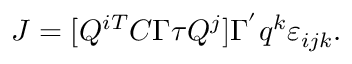<formula> <loc_0><loc_0><loc_500><loc_500>J = [ Q ^ { i T } C \Gamma \tau Q ^ { j } ] \Gamma ^ { ^ { \prime } } q ^ { k } \varepsilon _ { i j k } .</formula> 